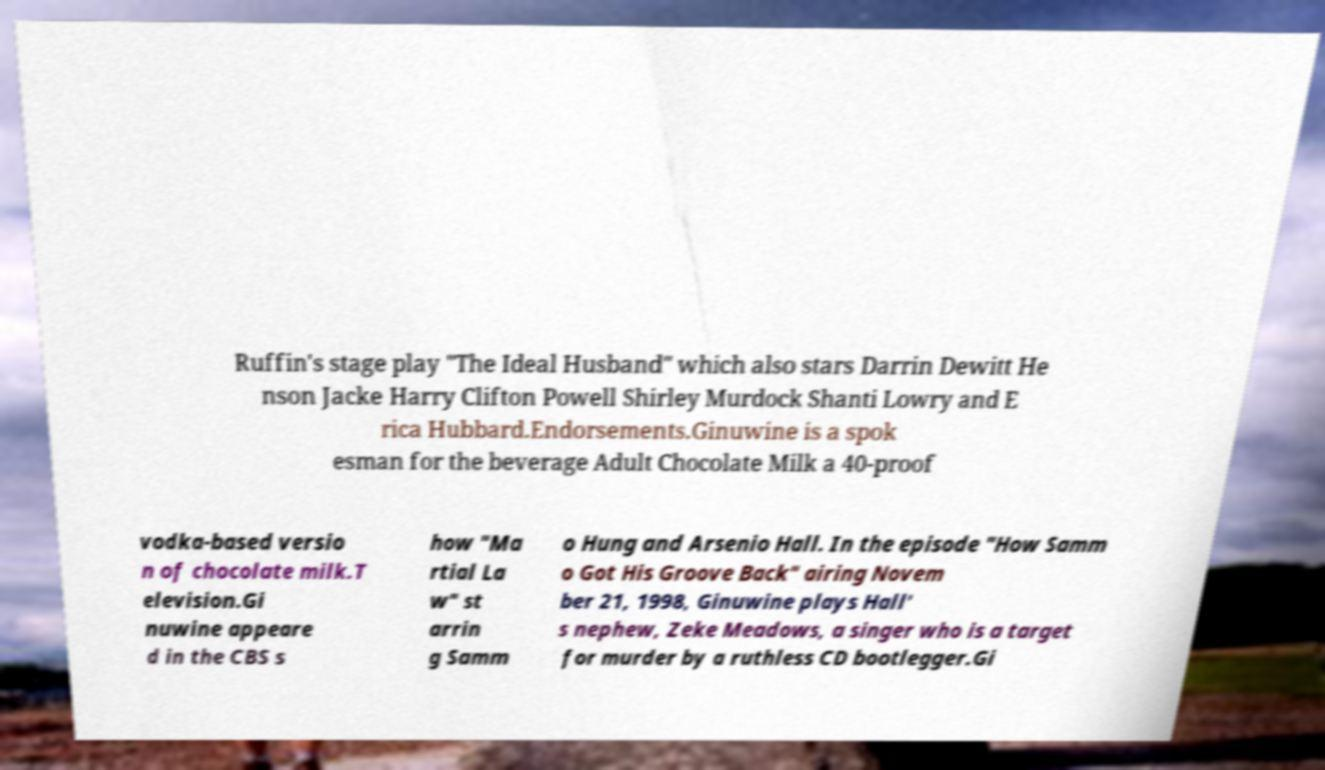Could you extract and type out the text from this image? Ruffin's stage play "The Ideal Husband" which also stars Darrin Dewitt He nson Jacke Harry Clifton Powell Shirley Murdock Shanti Lowry and E rica Hubbard.Endorsements.Ginuwine is a spok esman for the beverage Adult Chocolate Milk a 40-proof vodka-based versio n of chocolate milk.T elevision.Gi nuwine appeare d in the CBS s how "Ma rtial La w" st arrin g Samm o Hung and Arsenio Hall. In the episode "How Samm o Got His Groove Back" airing Novem ber 21, 1998, Ginuwine plays Hall' s nephew, Zeke Meadows, a singer who is a target for murder by a ruthless CD bootlegger.Gi 